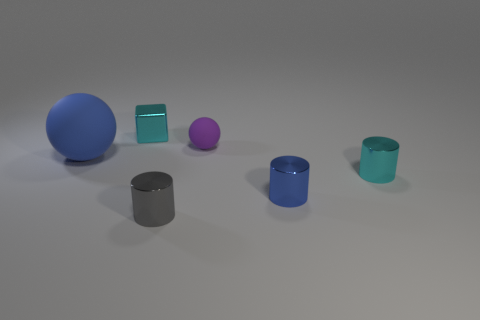Subtract all small blue cylinders. How many cylinders are left? 2 Add 2 green rubber blocks. How many objects exist? 8 Subtract 1 cylinders. How many cylinders are left? 2 Subtract all balls. How many objects are left? 4 Subtract all red cylinders. Subtract all brown balls. How many cylinders are left? 3 Add 4 small things. How many small things exist? 9 Subtract 0 purple cylinders. How many objects are left? 6 Subtract all blue matte things. Subtract all big green things. How many objects are left? 5 Add 4 tiny purple spheres. How many tiny purple spheres are left? 5 